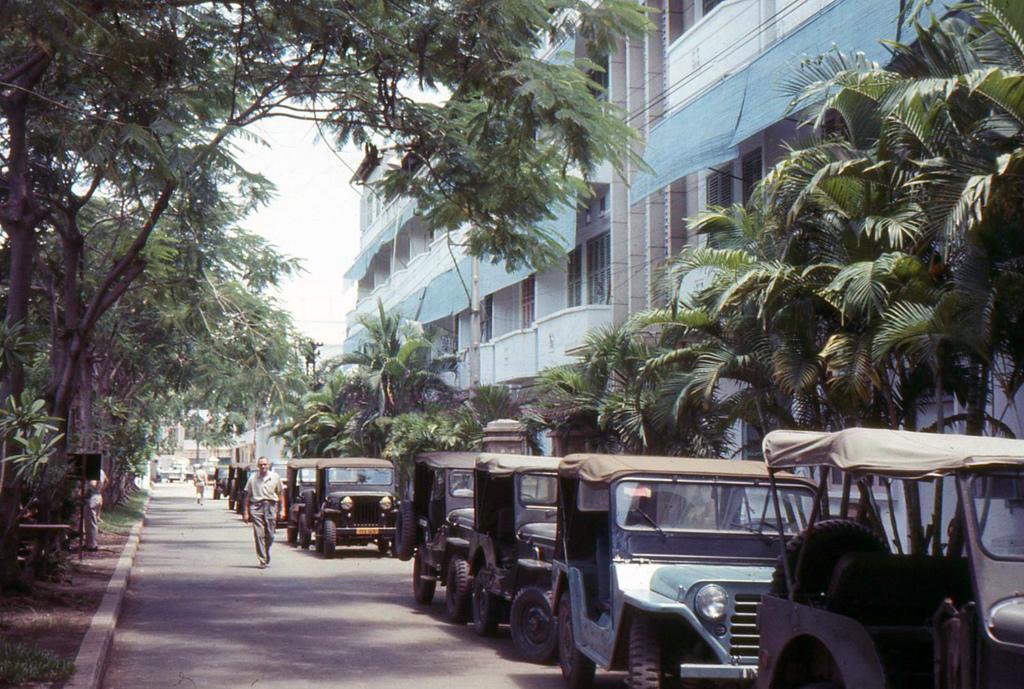Please provide a concise description of this image. In this image I can see few people and many vehicles on the road. On both sides of the road I can see many trees. In the background I can see the building and the sky. 